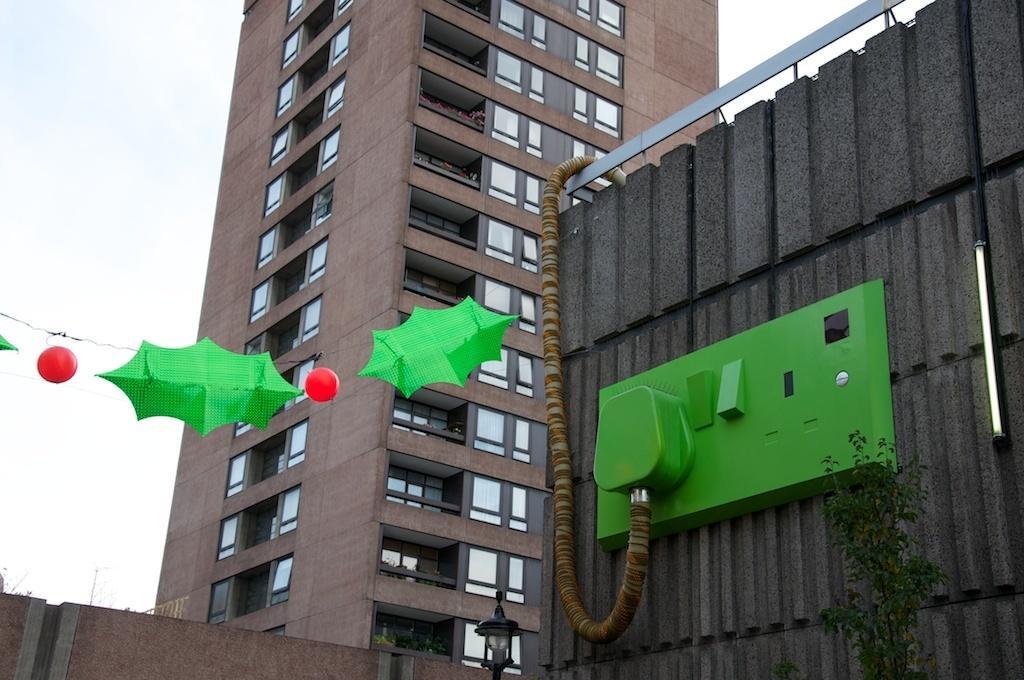Could you give a brief overview of what you see in this image? On the right side, there is a green color plug inserted into the green color plug board which is having green color switches. This plug board is attached to the wall of a building. On the left side, there are green color decorative papers and red color objects attached to the thread. In the background, there is a building which is having glass windows, there is wall and there are clouds in the sky. 